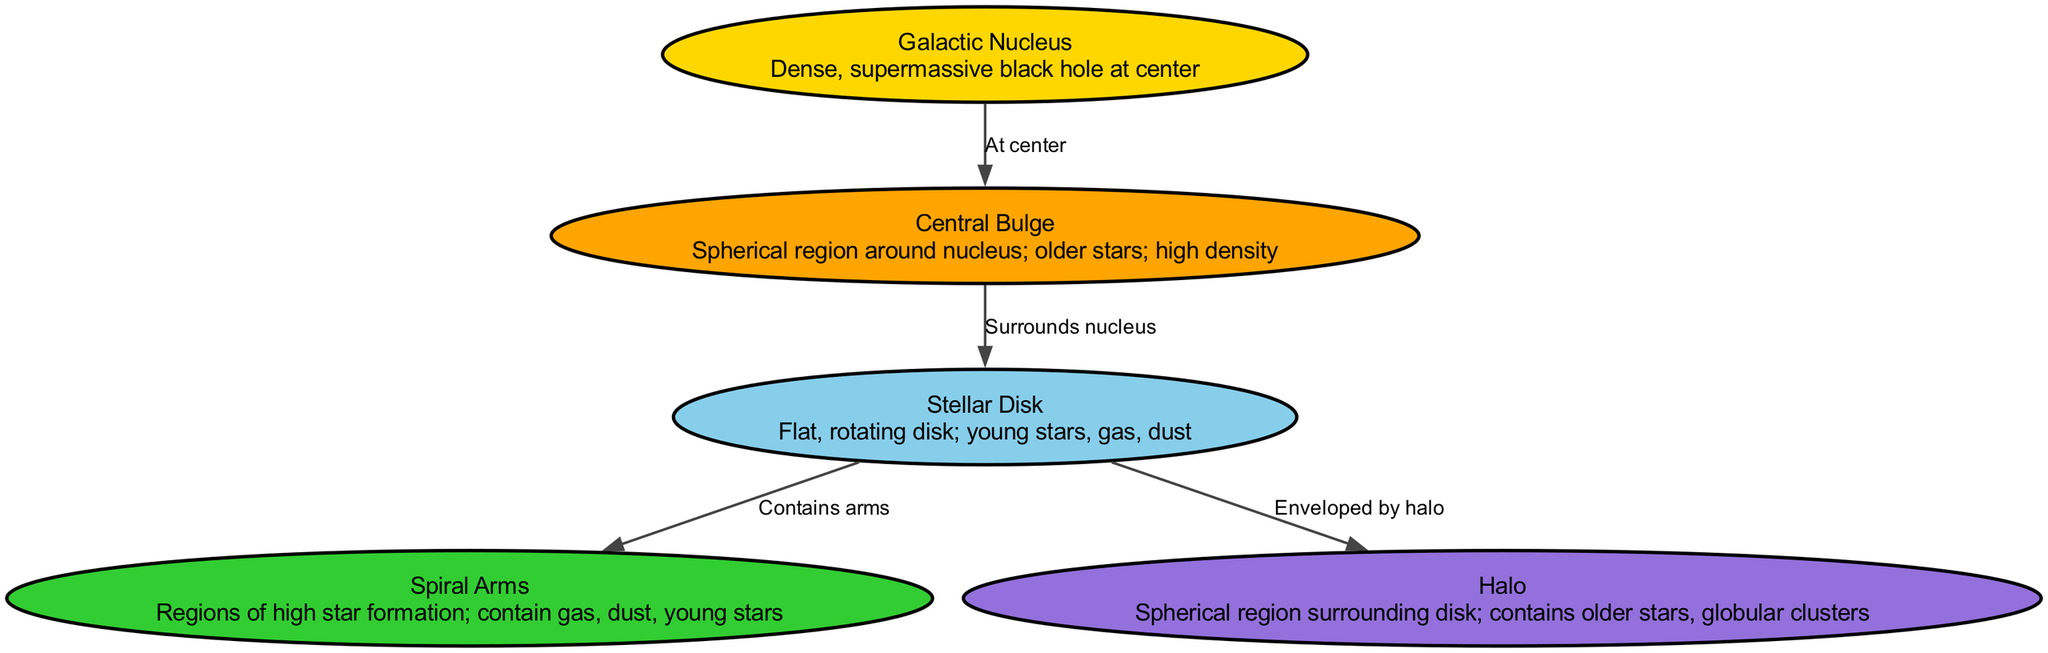What is at the center of the Milky Way galaxy? The diagram specifically identifies the Galactic Nucleus as the center of the Milky Way galaxy, which is described as a dense, supermassive black hole.
Answer: Galactic Nucleus How many main regions are labeled in the diagram? By counting the nodes provided in the data, there are five main regions: Galactic Nucleus, Central Bulge, Stellar Disk, Spiral Arms, and Halo.
Answer: Five Which region surrounds the nucleus of the Milky Way? The diagram states that the Central Bulge surrounds the Galactic Nucleus, as indicated by the direct connection between them in the edges section.
Answer: Central Bulge What color represents the Stellar Disk in the diagram? The color coding in the diagram defines the Stellar Disk as being represented by Sky Blue. This can be found by looking at the colors associated with each node.
Answer: Sky Blue Which two regions are connected directly by the Stellar Disk in the diagram? The edges indicate that the Stellar Disk contains the Spiral Arms and is enveloped by the Halo, thus connecting these two regions.
Answer: Spiral Arms and Halo What type of stars are primarily found in the Halo region? The Halo is described in the data as containing older stars and globular clusters; therefore, it primarily houses older stars.
Answer: Older stars How does the Stellar Disk relate to the Spiral Arms according to the diagram? The diagram shows a direct connection from the Stellar Disk to the Spiral Arms, indicating that the Stellar Disk contains the Spiral Arms. This means the arms are a part of the disk structure.
Answer: Contains Which section is identified as a region of high star formation? The diagram describes the Spiral Arms as regions of high star formation, highlighting their significant role in the overall stellar dynamics of the Milky Way.
Answer: Spiral Arms What surrounds the Stellar Disk according to the diagram? The edges reveal that the Halo envelops the Stellar Disk, indicating that the Stellar Disk is located beneath the Halo region.
Answer: Halo 